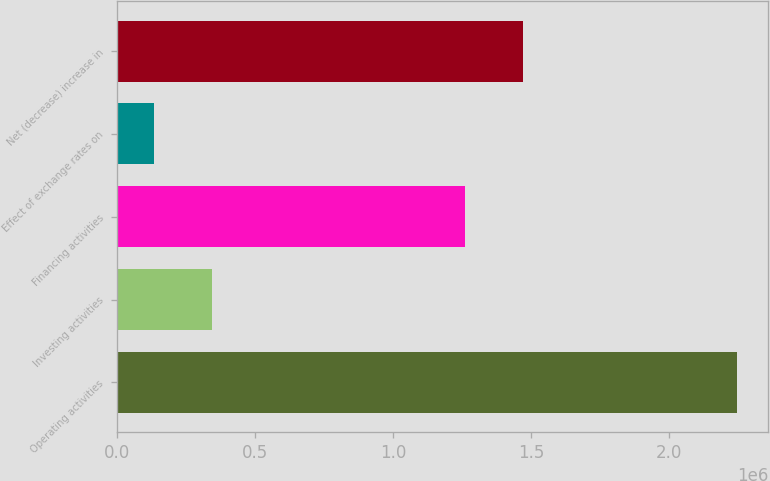Convert chart. <chart><loc_0><loc_0><loc_500><loc_500><bar_chart><fcel>Operating activities<fcel>Investing activities<fcel>Financing activities<fcel>Effect of exchange rates on<fcel>Net (decrease) increase in<nl><fcel>2.24779e+06<fcel>344709<fcel>1.26069e+06<fcel>133255<fcel>1.47214e+06<nl></chart> 